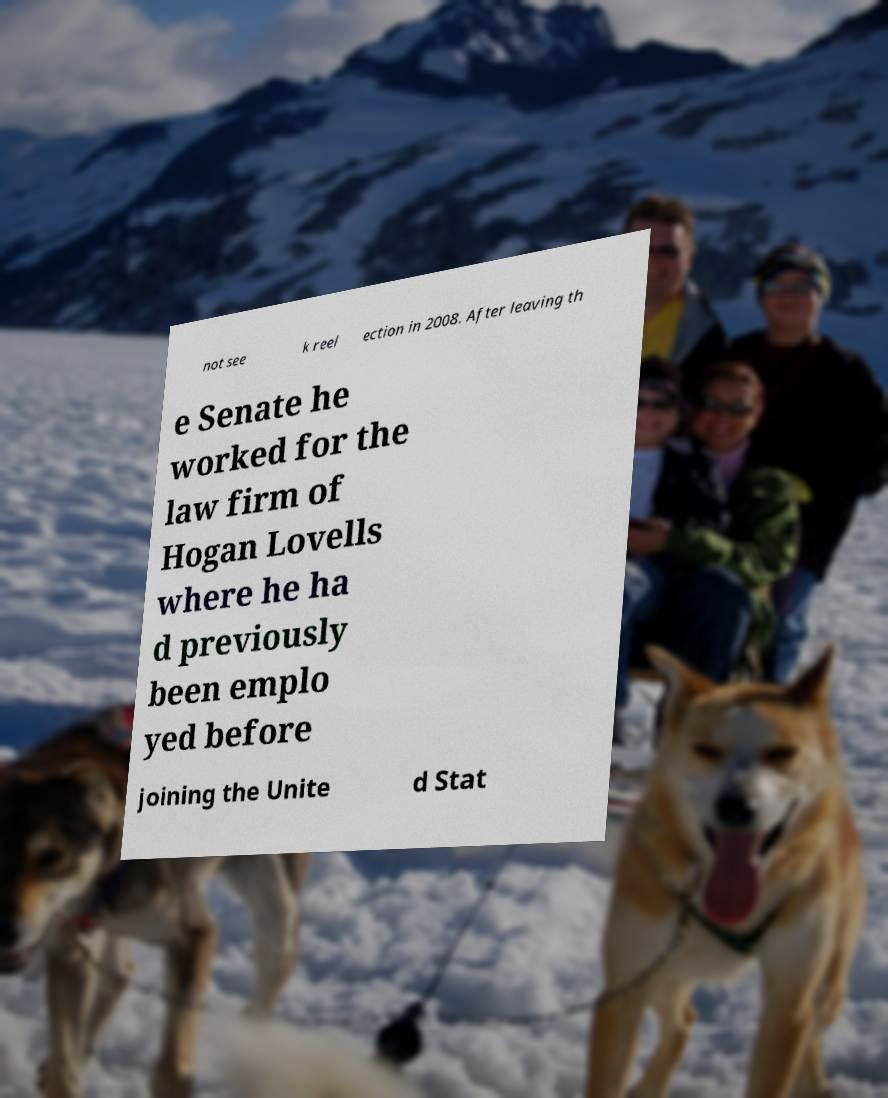Can you accurately transcribe the text from the provided image for me? not see k reel ection in 2008. After leaving th e Senate he worked for the law firm of Hogan Lovells where he ha d previously been emplo yed before joining the Unite d Stat 